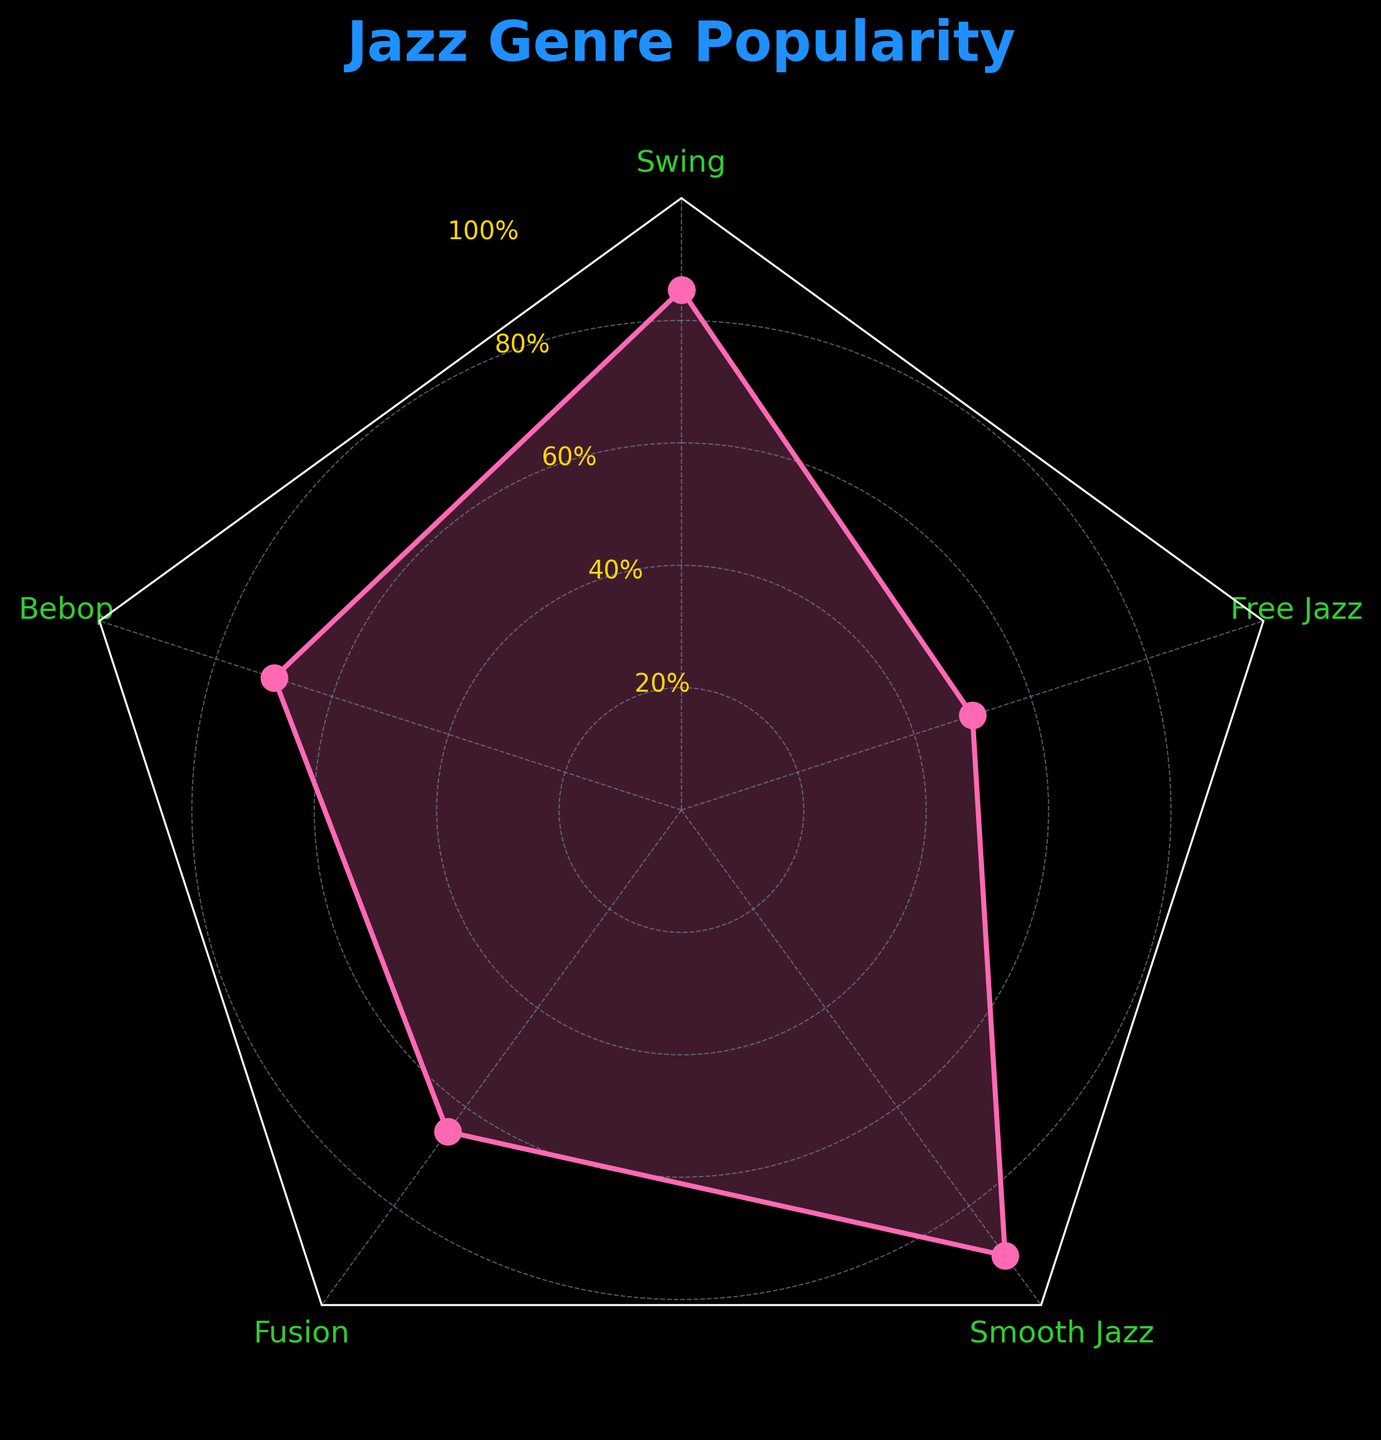What is the title of the radar chart? The title is usually located at the top of the figure. It summarizes the primary focus of the chart. The title in this chart reads "Jazz Genre Popularity".
Answer: Jazz Genre Popularity How many jazz genres are compared in the radar chart? The radar chart has points corresponding to each jazz genre that is being compared. By counting the labels around the radar chart, we can determine there are 5 genres being compared.
Answer: 5 Which jazz genre has the highest popularity score? To find the highest popularity score, look for the genre where the data point reaches the outermost layer of the chart. The Smooth Jazz score extends furthest among all.
Answer: Smooth Jazz How does the popularity score of Bebop compare to Fusion? Check the lengths of the lines corresponding to Bebop and Fusion. Bebop has a popularity score of 70, whereas Fusion has a score of 65. So, Bebop is more popular than Fusion.
Answer: Bebop What is the average popularity score of all the genres? To calculate the average, add all the popularity scores (85 + 70 + 65 + 90 + 50 = 360), then divide by the number of genres (5). This gives 360 / 5 = 72.
Answer: 72 What are the popularity scores that are exactly 20 points apart? Check which pairs of scores have a difference of exactly 20. The scores for Swing (85) and Bebop (70), and Uplifting (75) and Soft (55) meet this criterion, both differing by 15 points.
Answer: Swing and Bebop Which genre has the lowest popularity score among attendees? The lowest popularity score can be identified by the point closest to the center of the radar chart. Free Jazz has the lowest score of 50.
Answer: Free Jazz By how much does the popularity of Smooth Jazz exceed Fusion? Calculate the difference between the popularity scores of Smooth Jazz and Fusion. Smooth Jazz has 90, and Fusion has 65, so the difference is 90 - 65 = 25.
Answer: 25 What is the median popularity score among the jazz genres? To find the median, list all scores in ascending order and find the middle value. The scores are 50, 65, 70, 85, 90. The middle score is 70, so the median is 70.
Answer: 70 Which genres have a score greater than 80? Identify the genres with scores above 80 by checking the values. Swing with 85 and Smooth Jazz with 90 have scores greater than 80.
Answer: Swing and Smooth Jazz 